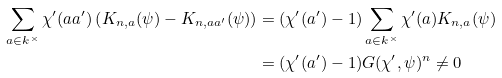<formula> <loc_0><loc_0><loc_500><loc_500>\sum _ { a \in k ^ { \times } } \chi ^ { \prime } ( a a ^ { \prime } ) \left ( K _ { n , a } ( \psi ) - K _ { n , a a ^ { \prime } } ( \psi ) \right ) & = ( \chi ^ { \prime } ( a ^ { \prime } ) - 1 ) \sum _ { a \in k ^ { \times } } \chi ^ { \prime } ( a ) K _ { n , a } ( \psi ) \\ & = ( \chi ^ { \prime } ( a ^ { \prime } ) - 1 ) G ( \chi ^ { \prime } , \psi ) ^ { n } \neq 0</formula> 